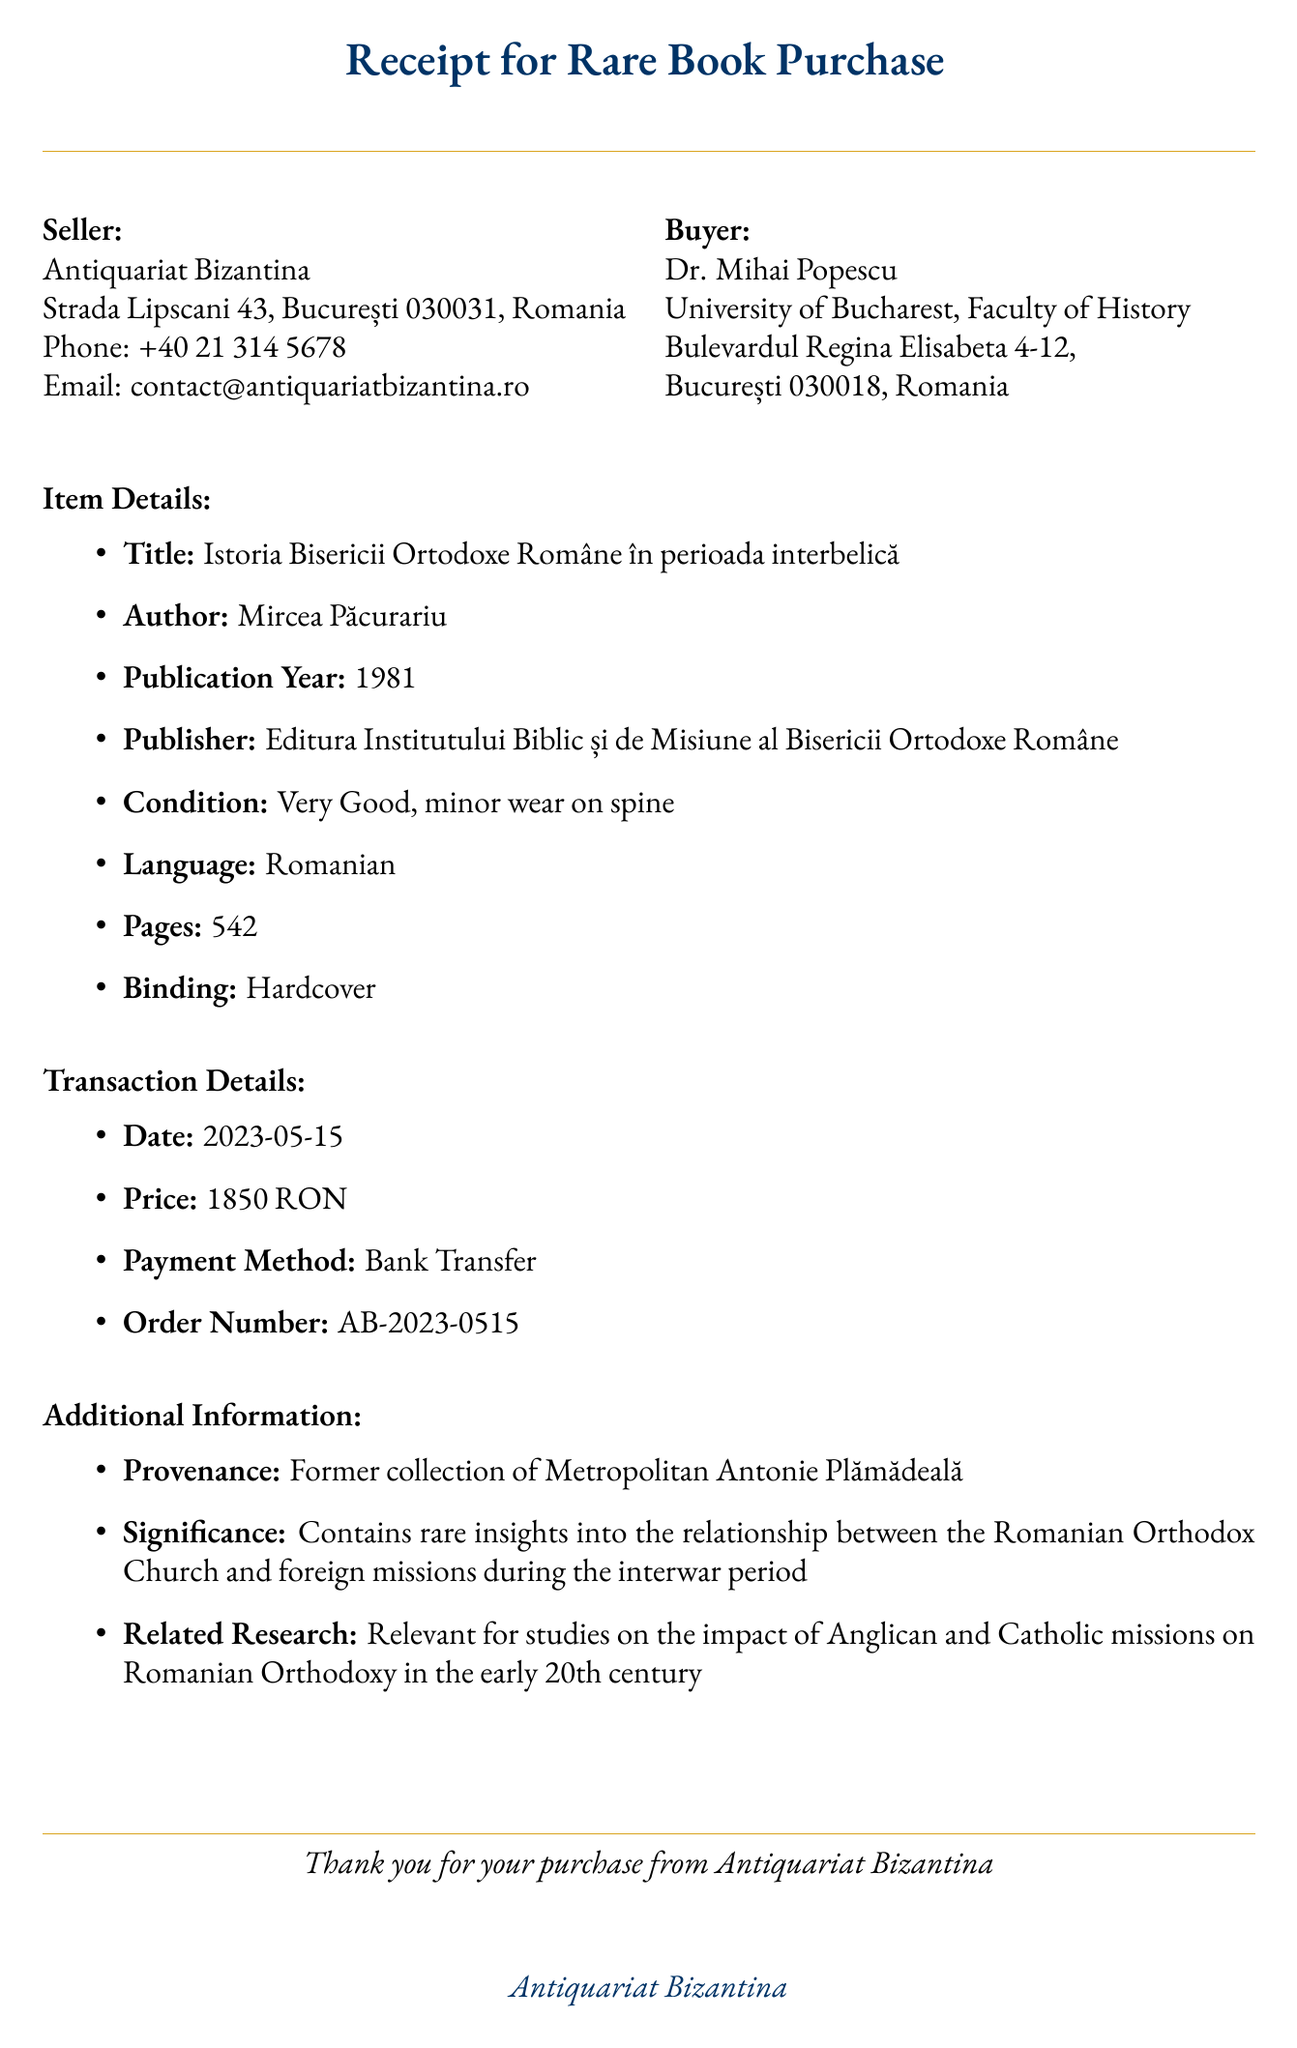What is the seller's name? The seller's name is listed at the beginning of the document under the seller's section.
Answer: Antiquariat Bizantina What is the title of the book? The title of the book is mentioned in the item details section of the receipt.
Answer: Istoria Bisericii Ortodoxe Române în perioada interbelică Who is the author of the book? The author's name is provided in the item details section of the document.
Answer: Mircea Păcurariu What is the publication year of the book? The publication year is specifically listed in the item details section.
Answer: 1981 What is the total price of the book? The total price is stated in the transaction details section of the receipt.
Answer: 1850 RON What is the condition of the book? The condition is mentioned in the item details and outlines its quality.
Answer: Very Good, minor wear on spine What is the provenance of the book? The provenance is included in the additional information section, indicating its previous ownership.
Answer: Former collection of Metropolitan Antonie Plămădeală What payment method was used for the transaction? The payment method is listed in the transaction details, specifying how payment was made.
Answer: Bank Transfer What significance does the book hold? The significance is noted in the additional information section, describing its importance in research.
Answer: Contains rare insights into the relationship between the Romanian Orthodox Church and foreign missions during the interwar period 